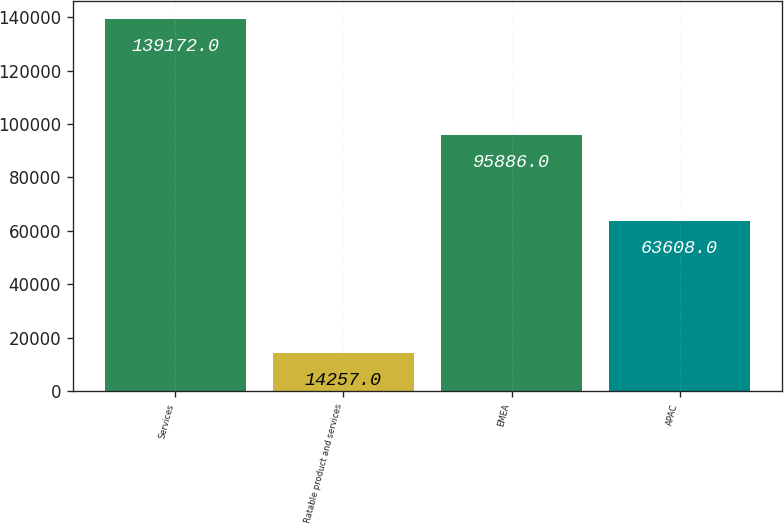Convert chart to OTSL. <chart><loc_0><loc_0><loc_500><loc_500><bar_chart><fcel>Services<fcel>Ratable product and services<fcel>EMEA<fcel>APAC<nl><fcel>139172<fcel>14257<fcel>95886<fcel>63608<nl></chart> 